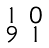<formula> <loc_0><loc_0><loc_500><loc_500>\begin{smallmatrix} 1 & 0 \\ 9 & 1 \end{smallmatrix}</formula> 